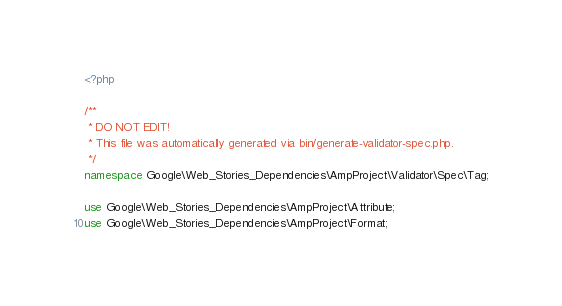Convert code to text. <code><loc_0><loc_0><loc_500><loc_500><_PHP_><?php

/**
 * DO NOT EDIT!
 * This file was automatically generated via bin/generate-validator-spec.php.
 */
namespace Google\Web_Stories_Dependencies\AmpProject\Validator\Spec\Tag;

use Google\Web_Stories_Dependencies\AmpProject\Attribute;
use Google\Web_Stories_Dependencies\AmpProject\Format;</code> 